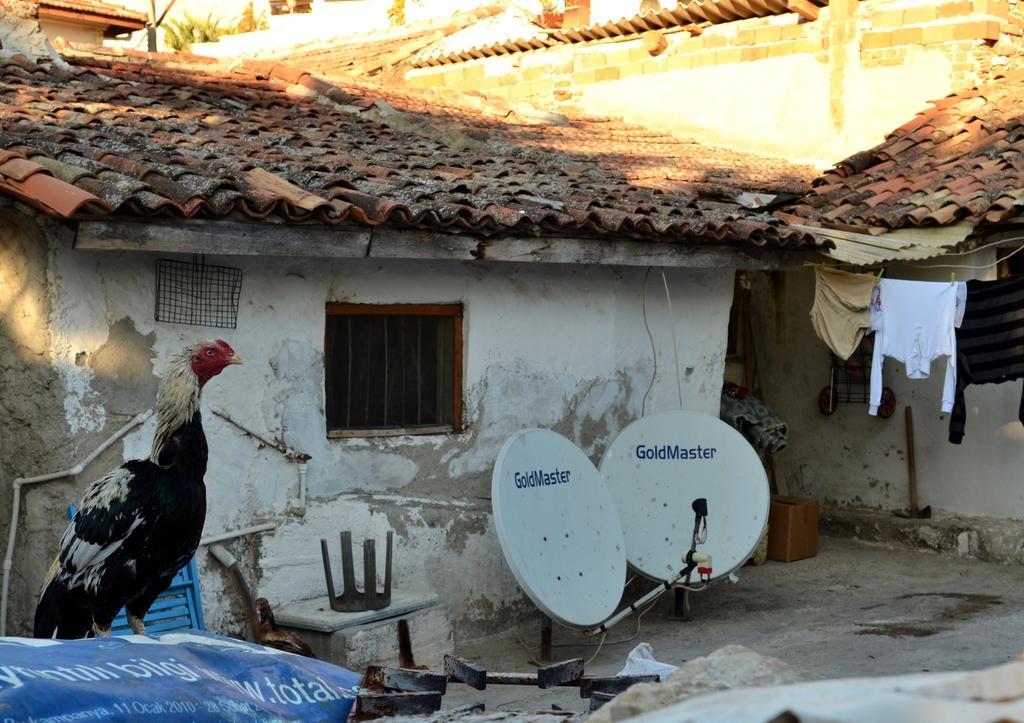Describe this image in one or two sentences. In this picture I can see a hen on the left side. In the middle there are satellite dishes and houses. On the right side I can see few clothes. 